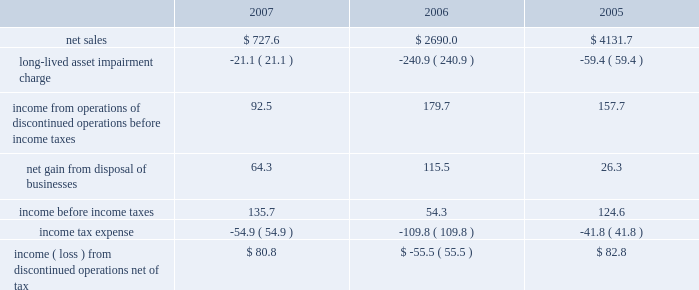Notes to consolidated financial statements 2014 ( continued ) fiscal years ended may 27 , 2007 , may 28 , 2006 , and may 29 , 2005 columnar amounts in millions except per share amounts due to the purchase price of the cattle feeding business being entirely financed by the company , the legal divestiture of the cattle feeding operation was not recognized as a divestiture for accounting purposes , and the assets , liabilities and results of operations of the cattle feeding business were reflected in continuing operations in the company 2019s financial statements prior to october 15 , 2004 .
On september 24 , 2004 , the company reached an agreement with affiliates of swift foods by which the company took control and ownership of approximately $ 300 million of the net assets of the cattle feeding business , including feedlots and live cattle .
On october 15 , 2004 , the company sold the feedlots to smithfield foods for approximately $ 70 million .
These transactions resulted in a gain of approximately $ 19 million ( net of taxes of $ 11.6 million ) .
The company retained live cattle inventory and related derivative instruments and liquidated those assets in an orderly manner over the succeeding several months .
Beginning september 24 , 2004 , the assets , liabilities and results of operations , including the gain on sale , of the cattle feeding business are classified as discontinued operations .
Culturelle business during the first quarter of fiscal 2007 , the company completed its divestiture of its nutritional supplement business for proceeds of approximately $ 8.2 million , resulting in a pre-tax gain of approximately $ 6.2 million ( $ 3.5 million after tax ) .
The company reflects this gain within discontinued operations .
The results of the aforementioned businesses which have been divested are included within discontinued operations .
The summary comparative financial results of discontinued operations were as follows: .
The effective tax rate for discontinued operations is significantly higher than the statutory rate due to the nondeductibility of certain goodwill of divested businesses .
Other assets held for sale during the third quarter of fiscal 2006 , the company initiated a plan to dispose of a refrigerated pizza business with annual revenues of less than $ 70 million .
During the second quarter of fiscal 2007 , the company disposed of this business for proceeds of approximately $ 22.0 million , resulting in no significant gain or loss .
Due to the company 2019s expected significant continuing cash flows associated with this business , the results of operations of this business are included in continuing operations for all periods presented .
The assets and liabilities of this business are classified as assets and liabilities held for sale in the consolidated balance sheets for all periods prior to the sale .
During the second quarter of fiscal 2007 , the company completed the disposal of an oat milling business for proceeds of approximately $ 35.8 million , after final working capital adjustments made during the third quarter .
For the 3 years ended 2007 income ( loss ) from discontinued operations net of tax totaled? 
Computations: ((80.8 + 82.8) - 55.5)
Answer: 108.1. 